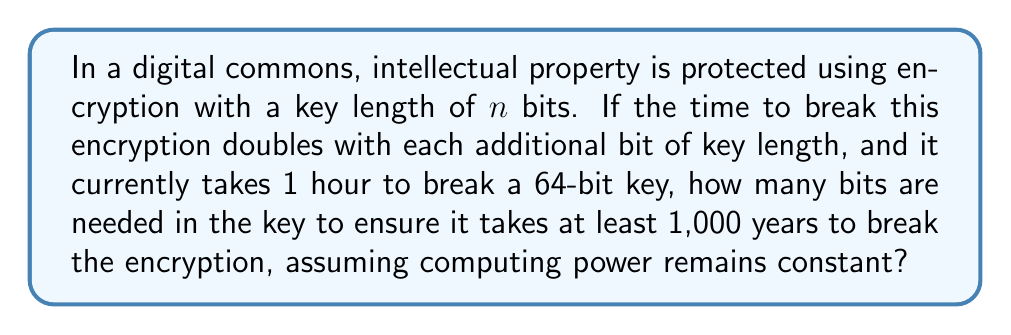Show me your answer to this math problem. Let's approach this step-by-step:

1) First, we need to convert 1,000 years to hours:
   $1000 \text{ years} \times 365 \text{ days/year} \times 24 \text{ hours/day} = 8,760,000 \text{ hours}$

2) We're told that it takes 1 hour to break a 64-bit key. Let's call our target key length $x$.

3) The time to break the encryption doubles with each additional bit, so we can express this as:
   $\text{Time to break} = 2^{x-64} \text{ hours}$

4) We want this time to be at least 8,760,000 hours, so:
   $2^{x-64} \geq 8,760,000$

5) Taking the logarithm (base 2) of both sides:
   $x - 64 \geq \log_2(8,760,000)$

6) Solving for $x$:
   $x \geq 64 + \log_2(8,760,000)$

7) Calculate $\log_2(8,760,000)$:
   $\log_2(8,760,000) \approx 23.06$

8) Therefore:
   $x \geq 64 + 23.06 = 87.06$

9) Since we need a whole number of bits, we round up to the next integer:
   $x = 88$

Thus, we need a key length of at least 88 bits to ensure it takes at least 1,000 years to break the encryption under the given conditions.
Answer: 88 bits 